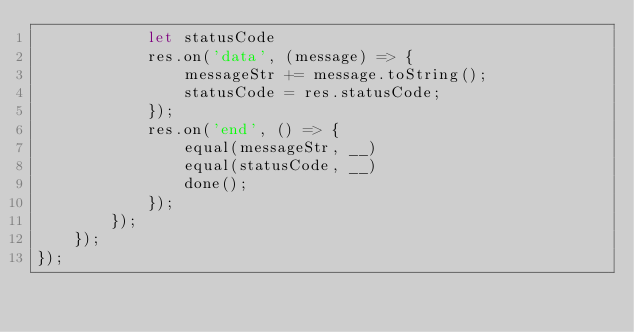<code> <loc_0><loc_0><loc_500><loc_500><_JavaScript_>            let statusCode
            res.on('data', (message) => {
                messageStr += message.toString();
                statusCode = res.statusCode;
            });
            res.on('end', () => {
                equal(messageStr, __)
                equal(statusCode, __)
                done();
            });
        });
    });
});
</code> 